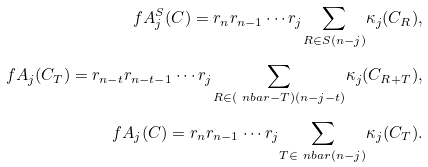<formula> <loc_0><loc_0><loc_500><loc_500>\ f A ^ { S } _ { j } ( C ) = r _ { n } r _ { n - 1 } \cdots r _ { j } \underset { R \in S ( n - j ) } { \sum } \kappa _ { j } ( C _ { R } ) , \\ \ f A _ { j } ( C _ { T } ) = r _ { n - t } r _ { n - t - 1 } \cdots r _ { j } \underset { R \in ( \ n b a r - T ) ( n - j - t ) } { \sum } \kappa _ { j } ( C _ { R + T } ) , \\ \ f A _ { j } ( C ) = r _ { n } r _ { n - 1 } \cdots r _ { j } \underset { T \in \ n b a r ( n - j ) } { \sum } \kappa _ { j } ( C _ { T } ) .</formula> 